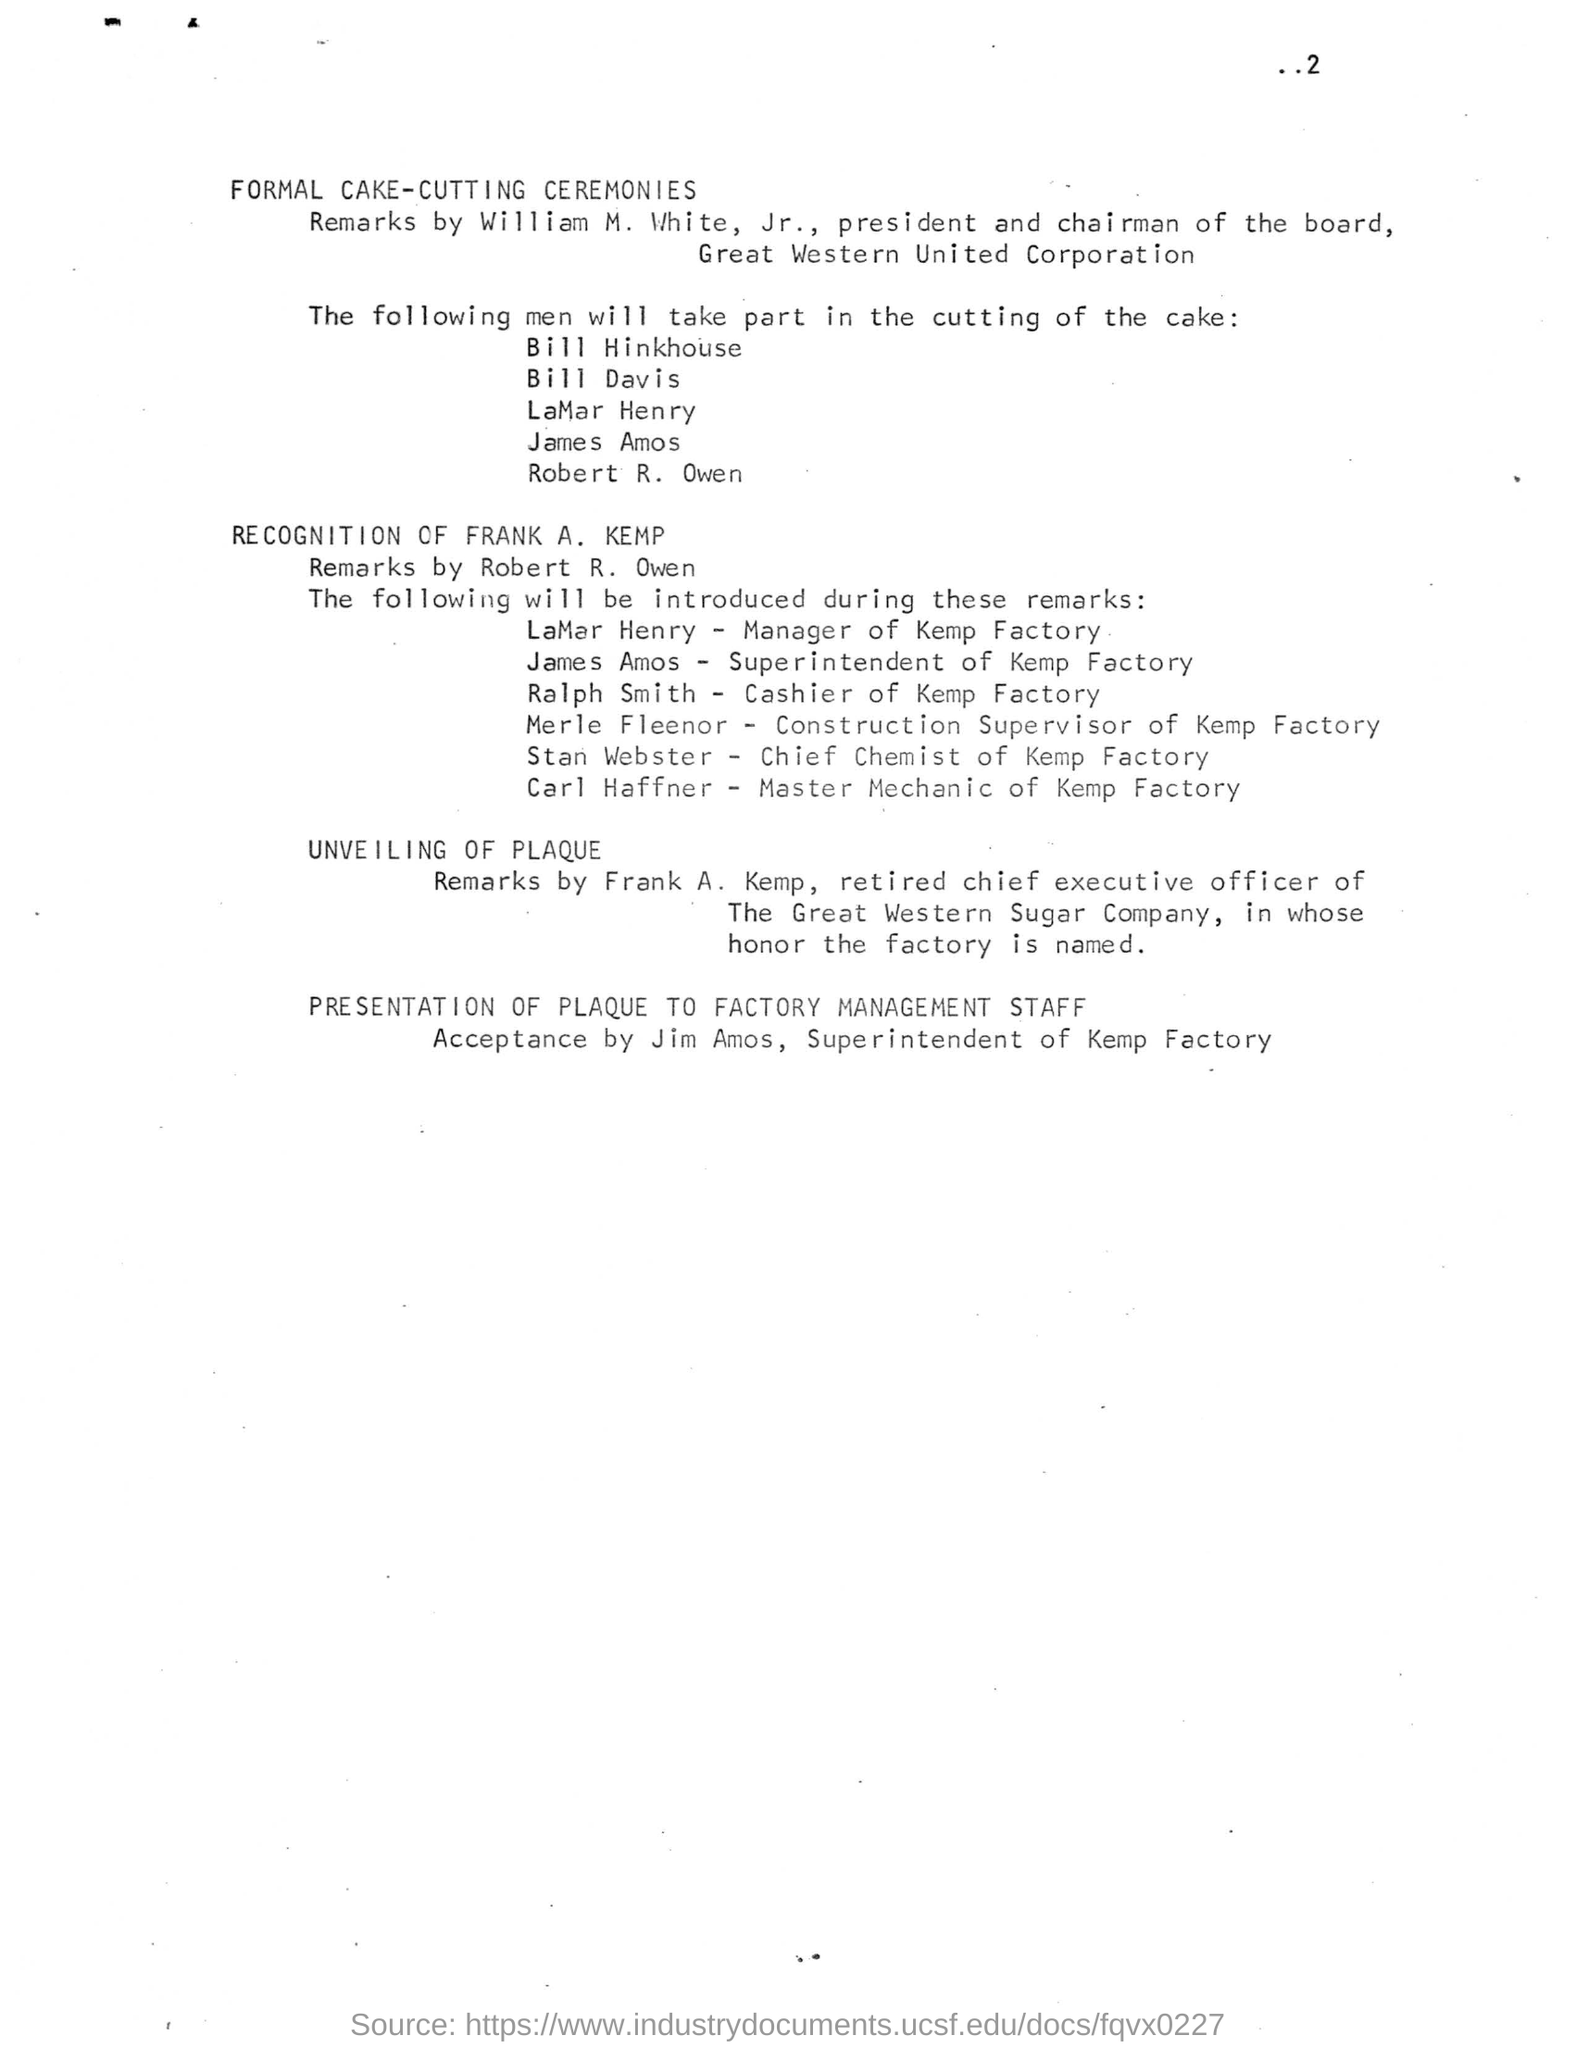Who was the president and chairman of the board of Great Western United Corporation?
Provide a succinct answer. WILLIAM M. WHITE, JR. In whose honor is the factory named?
Ensure brevity in your answer.  FRANK A.KEMP. Who is the manager of Kemp Factory?
Offer a terse response. LAMAR HENRY. 